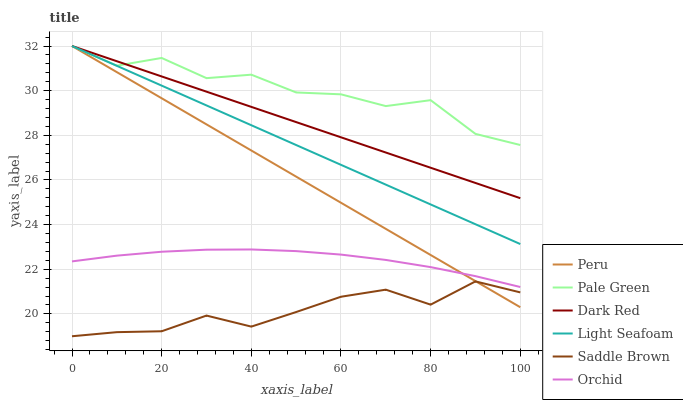Does Saddle Brown have the minimum area under the curve?
Answer yes or no. Yes. Does Pale Green have the maximum area under the curve?
Answer yes or no. Yes. Does Peru have the minimum area under the curve?
Answer yes or no. No. Does Peru have the maximum area under the curve?
Answer yes or no. No. Is Light Seafoam the smoothest?
Answer yes or no. Yes. Is Pale Green the roughest?
Answer yes or no. Yes. Is Peru the smoothest?
Answer yes or no. No. Is Peru the roughest?
Answer yes or no. No. Does Saddle Brown have the lowest value?
Answer yes or no. Yes. Does Peru have the lowest value?
Answer yes or no. No. Does Light Seafoam have the highest value?
Answer yes or no. Yes. Does Saddle Brown have the highest value?
Answer yes or no. No. Is Saddle Brown less than Dark Red?
Answer yes or no. Yes. Is Dark Red greater than Orchid?
Answer yes or no. Yes. Does Pale Green intersect Dark Red?
Answer yes or no. Yes. Is Pale Green less than Dark Red?
Answer yes or no. No. Is Pale Green greater than Dark Red?
Answer yes or no. No. Does Saddle Brown intersect Dark Red?
Answer yes or no. No. 